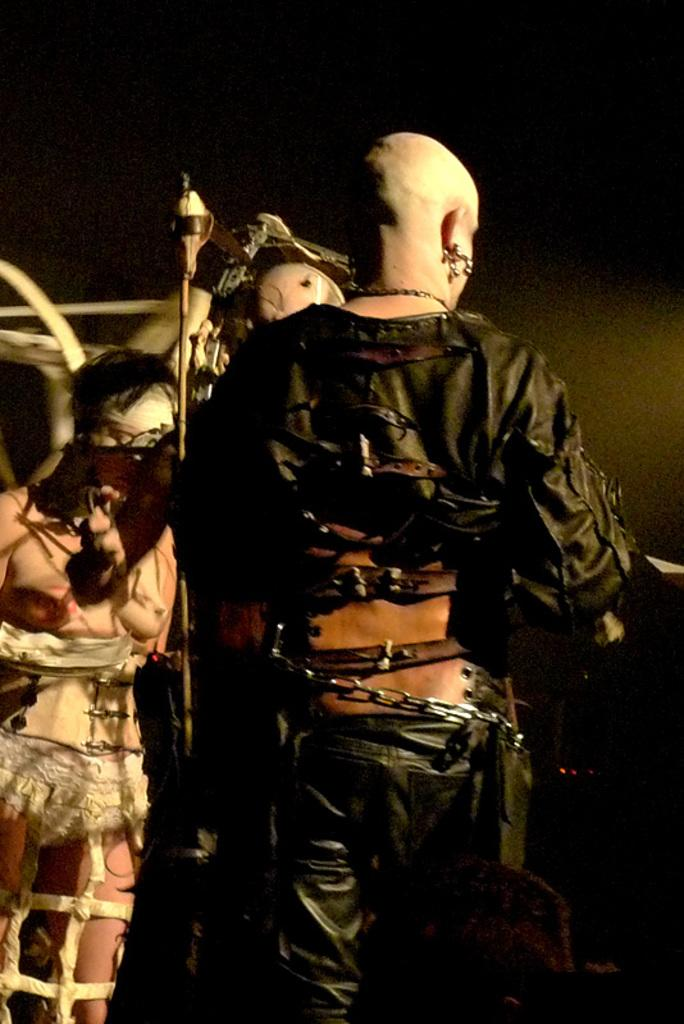Who or what is present in the image? There are people in the image. What are the people wearing? The people are wearing costumes. Can you describe any other objects or features in the image? There is a chain visible in the image. What can be seen in the background of the image? There is a wall in the background of the image. What is the average income of the people in the image? There is no information about the income of the people in the image, as it is not relevant to the visual content. --- Facts: 1. There is a car in the image. 2. The car is parked on the street. 3. There are trees in the background of the image. 4. The sky is visible in the image. Absurd Topics: dance, piano, ocean Conversation: What is the main subject of the image? The main subject of the image is a car. Where is the car located in the image? The car is parked on the street. What can be seen in the background of the image? There are trees in the background of the image. What else is visible in the image? The sky is visible in the image. Reasoning: Let's think step by step in order to produce the conversation. We start by identifying the main subject of the image, which is the car. Then, we describe the car's location, noting that it is parked on the street. Next, we mention any other objects or features that are visible in the background, such as the trees and the sky. Absurd Question/Answer: Can you hear the sound of the ocean in the image? There is no sound present in the image, and the image does not depict any ocean or body of water. 